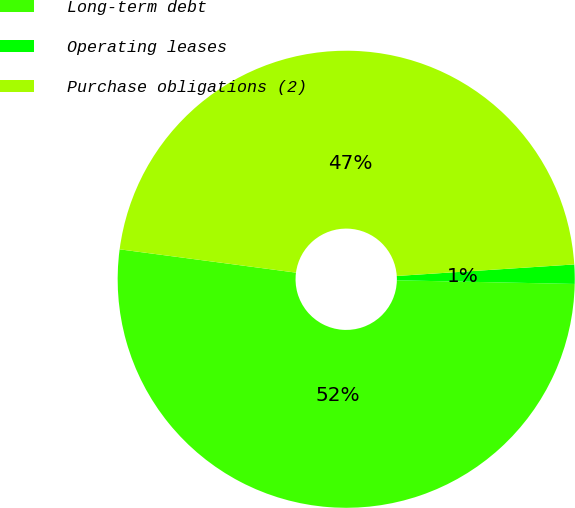Convert chart to OTSL. <chart><loc_0><loc_0><loc_500><loc_500><pie_chart><fcel>Long-term debt<fcel>Operating leases<fcel>Purchase obligations (2)<nl><fcel>51.77%<fcel>1.36%<fcel>46.88%<nl></chart> 